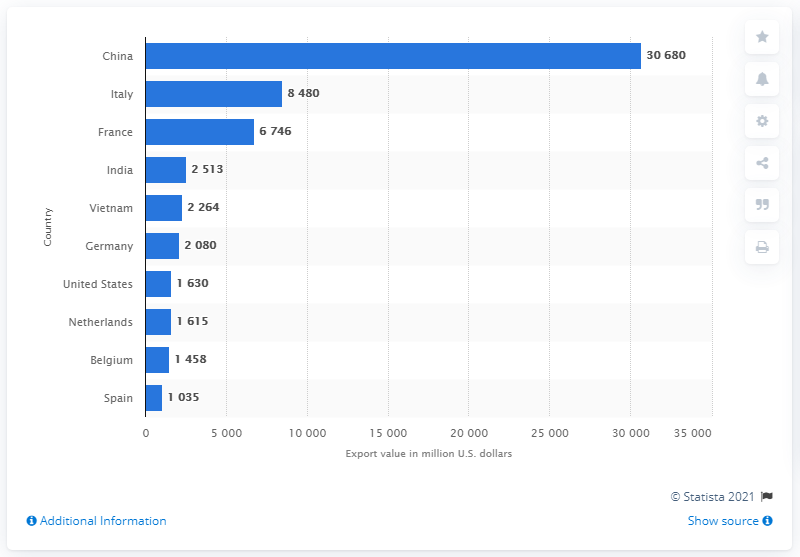Indicate a few pertinent items in this graphic. In 2013, the export value of China's leather goods was 30,680 million U.S. dollars. In 2013, China was the leading exporter of leather goods. 